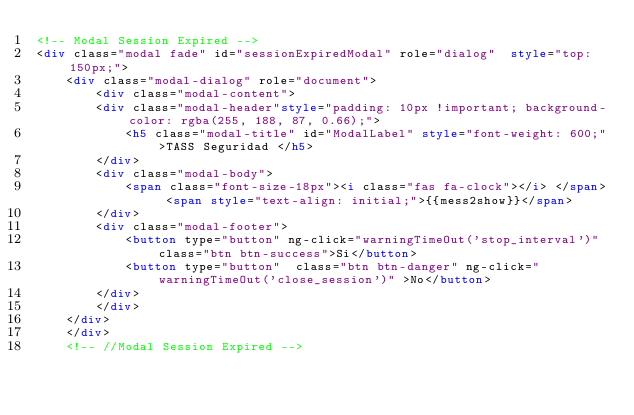<code> <loc_0><loc_0><loc_500><loc_500><_HTML_><!-- Modal Session Expired -->
<div class="modal fade" id="sessionExpiredModal" role="dialog"  style="top: 150px;">
    <div class="modal-dialog" role="document">
        <div class="modal-content">
        <div class="modal-header"style="padding: 10px !important; background-color: rgba(255, 188, 87, 0.66);">
            <h5 class="modal-title" id="ModalLabel" style="font-weight: 600;">TASS Seguridad </h5>
        </div>
        <div class="modal-body">
            <span class="font-size-18px"><i class="fas fa-clock"></i> </span> <span style="text-align: initial;">{{mess2show}}</span>
        </div>
        <div class="modal-footer">
            <button type="button" ng-click="warningTimeOut('stop_interval')" class="btn btn-success">Si</button>
            <button type="button"  class="btn btn-danger" ng-click="warningTimeOut('close_session')" >No</button>
        </div>
        </div>
    </div>
    </div>
    <!-- //Modal Session Expired --></code> 